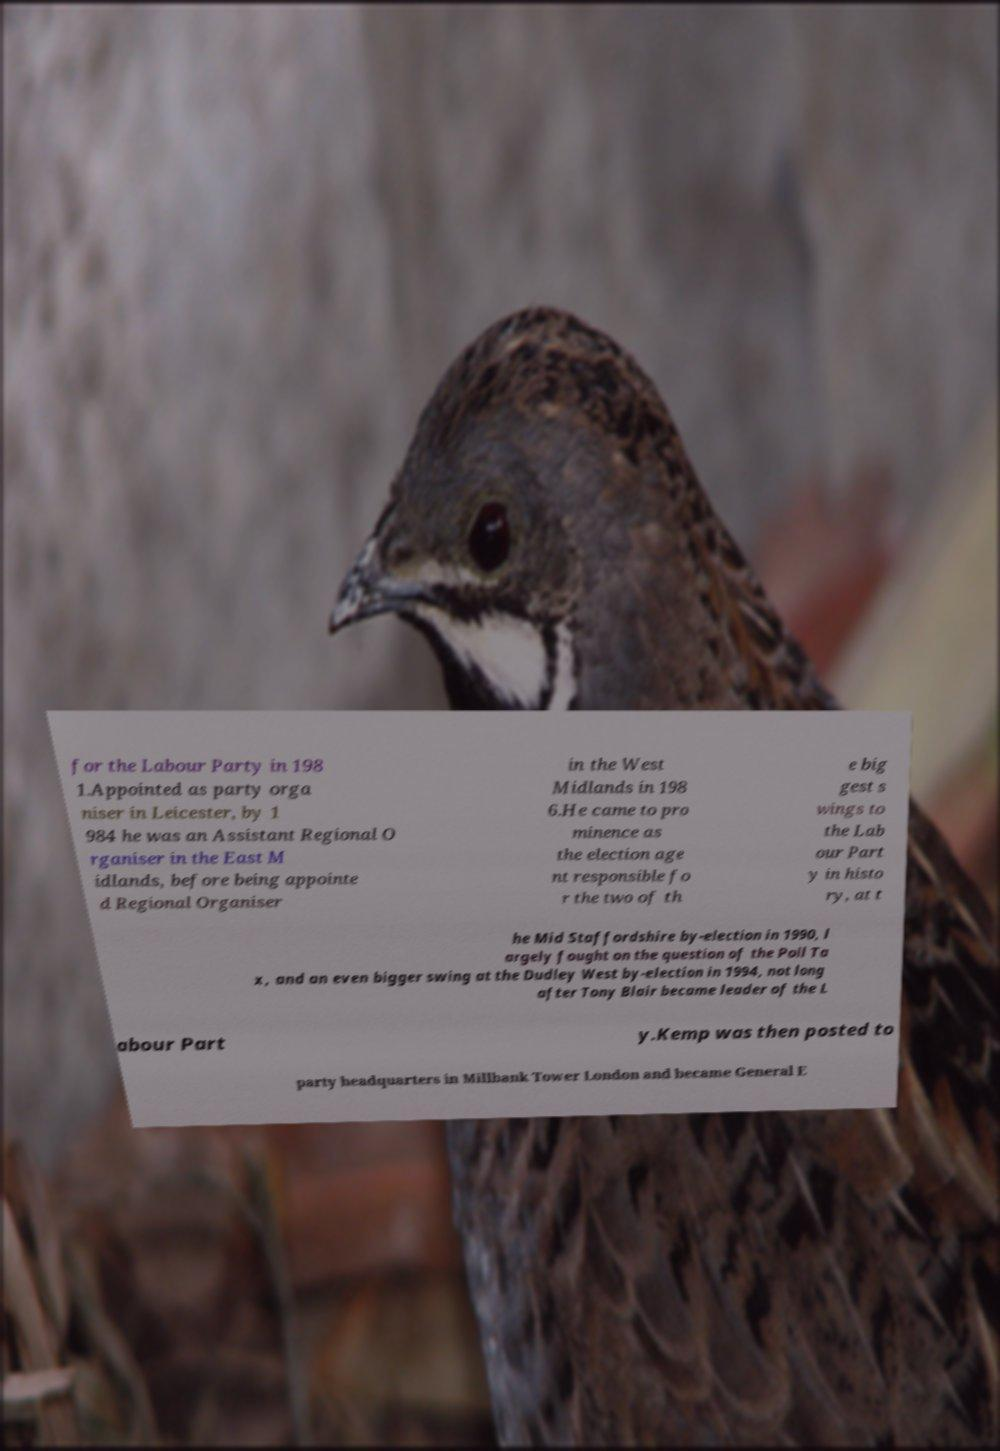Can you read and provide the text displayed in the image?This photo seems to have some interesting text. Can you extract and type it out for me? for the Labour Party in 198 1.Appointed as party orga niser in Leicester, by 1 984 he was an Assistant Regional O rganiser in the East M idlands, before being appointe d Regional Organiser in the West Midlands in 198 6.He came to pro minence as the election age nt responsible fo r the two of th e big gest s wings to the Lab our Part y in histo ry, at t he Mid Staffordshire by-election in 1990, l argely fought on the question of the Poll Ta x, and an even bigger swing at the Dudley West by-election in 1994, not long after Tony Blair became leader of the L abour Part y.Kemp was then posted to party headquarters in Millbank Tower London and became General E 